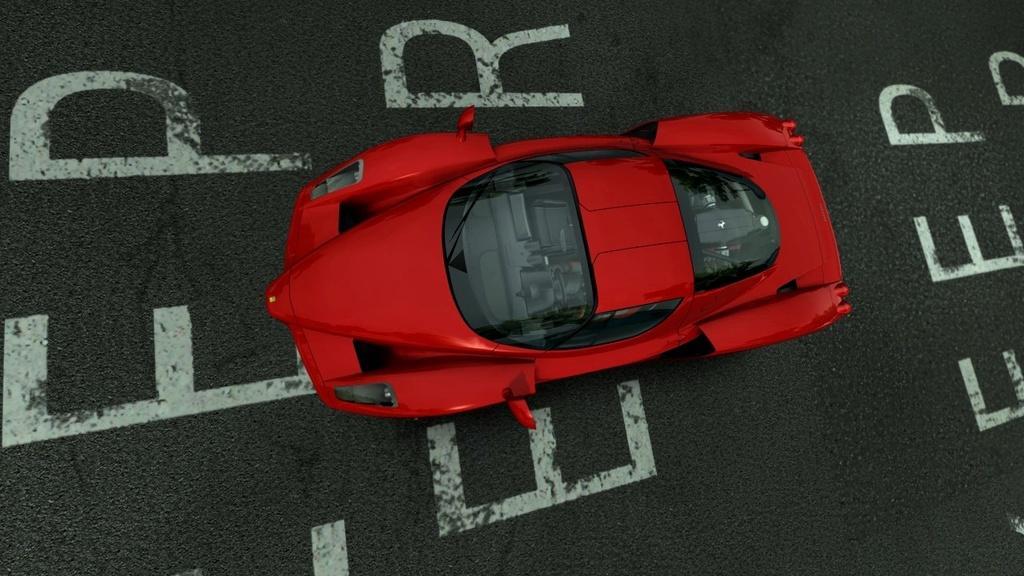In one or two sentences, can you explain what this image depicts? In the foreground of this image, there is a red color car on the road on which few text is written on it. 